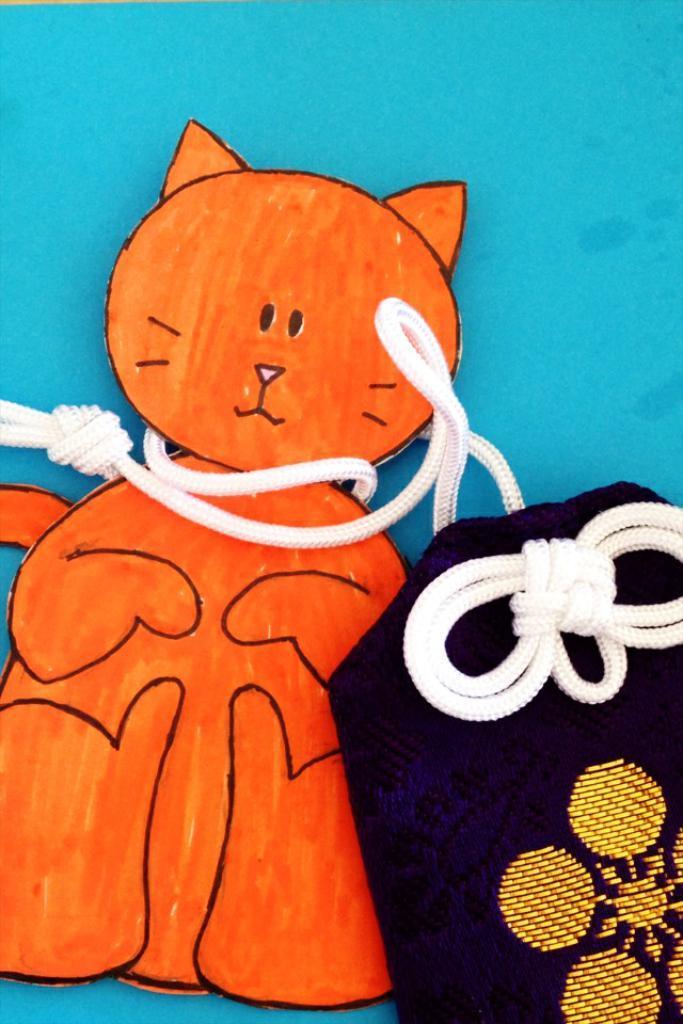In one or two sentences, can you explain what this image depicts? In this picture I can see a paper cat tied with the ropes to a pouch, on an object. 